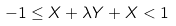<formula> <loc_0><loc_0><loc_500><loc_500>- 1 \leq X + \lambda Y + X < 1</formula> 